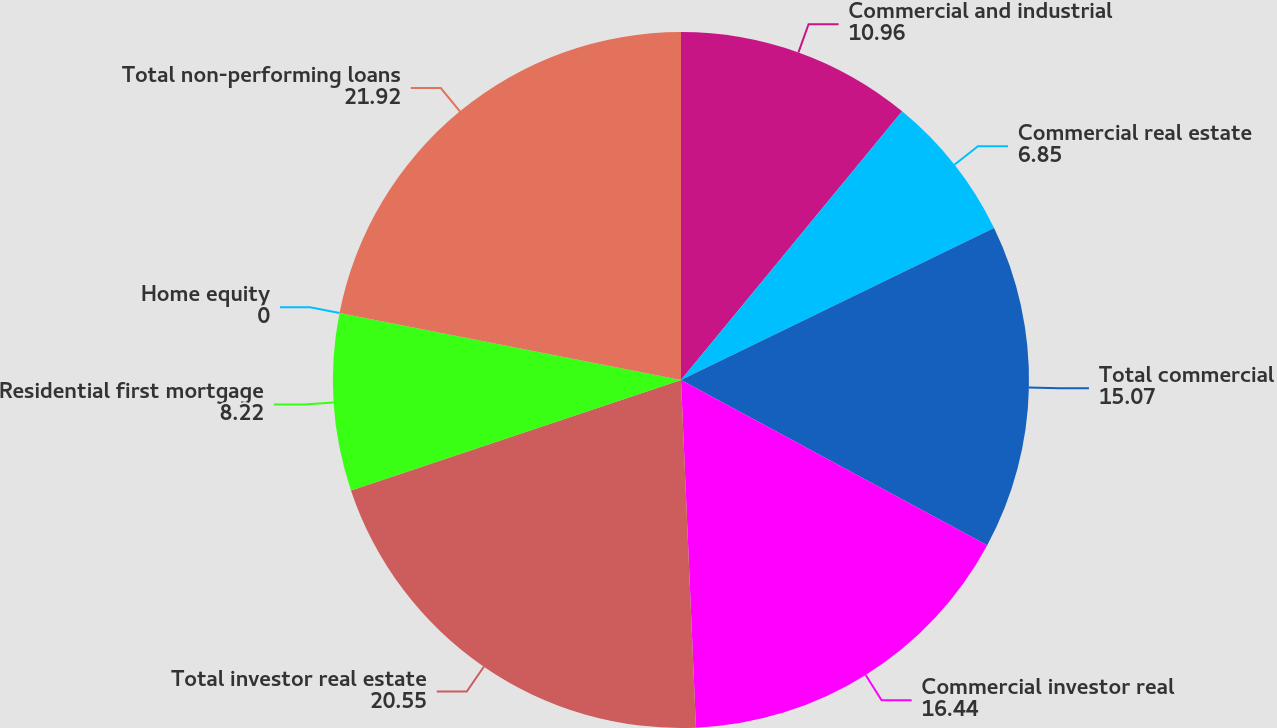<chart> <loc_0><loc_0><loc_500><loc_500><pie_chart><fcel>Commercial and industrial<fcel>Commercial real estate<fcel>Total commercial<fcel>Commercial investor real<fcel>Total investor real estate<fcel>Residential first mortgage<fcel>Home equity<fcel>Total non-performing loans<nl><fcel>10.96%<fcel>6.85%<fcel>15.07%<fcel>16.44%<fcel>20.55%<fcel>8.22%<fcel>0.0%<fcel>21.92%<nl></chart> 